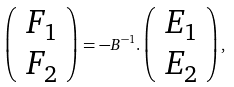Convert formula to latex. <formula><loc_0><loc_0><loc_500><loc_500>\left ( \begin{array} { c c } F _ { 1 } \\ F _ { 2 } \end{array} \right ) = - B ^ { - 1 } . \left ( \begin{array} { c c } E _ { 1 } \\ E _ { 2 } \end{array} \right ) ,</formula> 